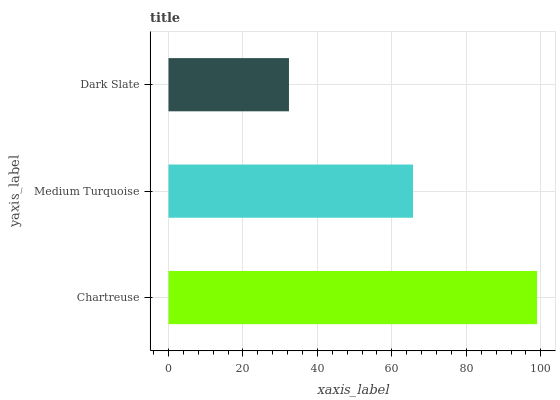Is Dark Slate the minimum?
Answer yes or no. Yes. Is Chartreuse the maximum?
Answer yes or no. Yes. Is Medium Turquoise the minimum?
Answer yes or no. No. Is Medium Turquoise the maximum?
Answer yes or no. No. Is Chartreuse greater than Medium Turquoise?
Answer yes or no. Yes. Is Medium Turquoise less than Chartreuse?
Answer yes or no. Yes. Is Medium Turquoise greater than Chartreuse?
Answer yes or no. No. Is Chartreuse less than Medium Turquoise?
Answer yes or no. No. Is Medium Turquoise the high median?
Answer yes or no. Yes. Is Medium Turquoise the low median?
Answer yes or no. Yes. Is Chartreuse the high median?
Answer yes or no. No. Is Dark Slate the low median?
Answer yes or no. No. 